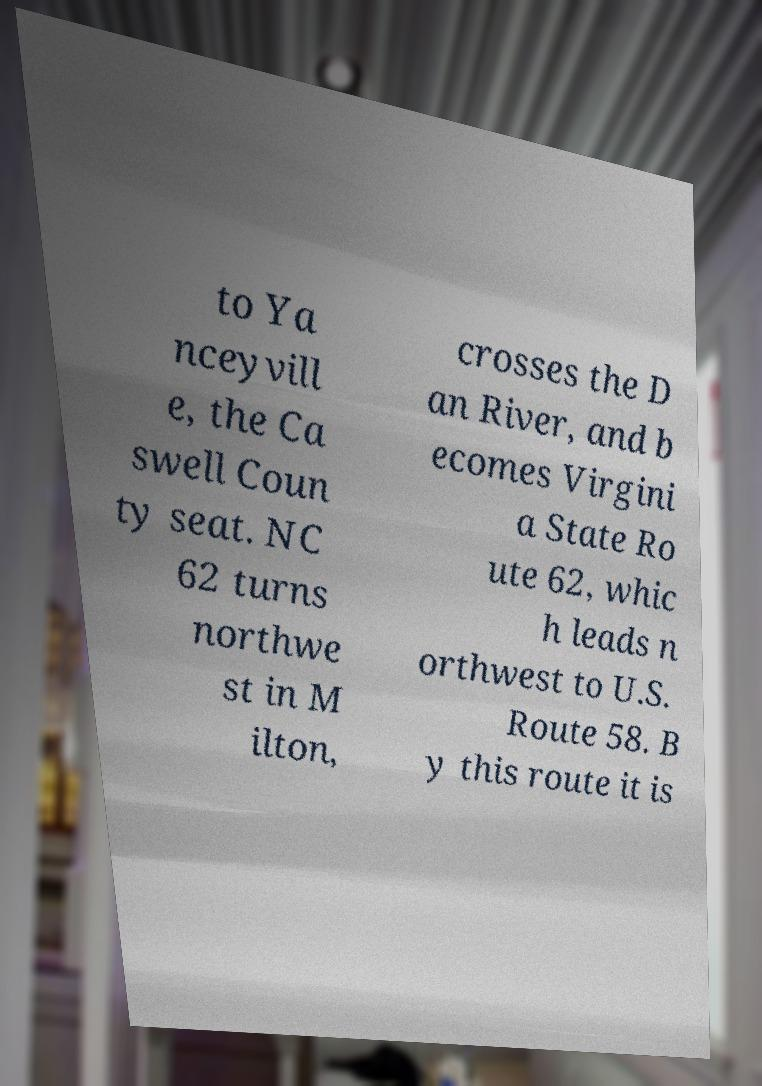I need the written content from this picture converted into text. Can you do that? to Ya nceyvill e, the Ca swell Coun ty seat. NC 62 turns northwe st in M ilton, crosses the D an River, and b ecomes Virgini a State Ro ute 62, whic h leads n orthwest to U.S. Route 58. B y this route it is 